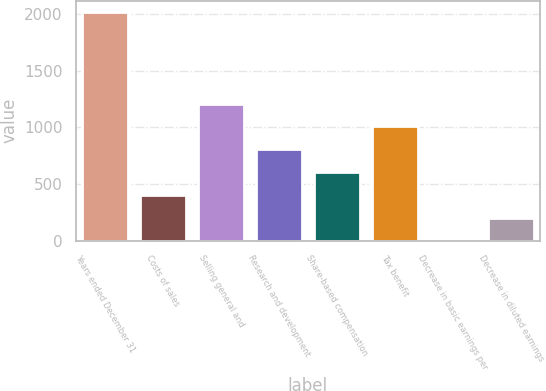Convert chart to OTSL. <chart><loc_0><loc_0><loc_500><loc_500><bar_chart><fcel>Years ended December 31<fcel>Costs of sales<fcel>Selling general and<fcel>Research and development<fcel>Share-based compensation<fcel>Tax benefit<fcel>Decrease in basic earnings per<fcel>Decrease in diluted earnings<nl><fcel>2014<fcel>403.02<fcel>1208.5<fcel>805.76<fcel>604.39<fcel>1007.13<fcel>0.28<fcel>201.65<nl></chart> 